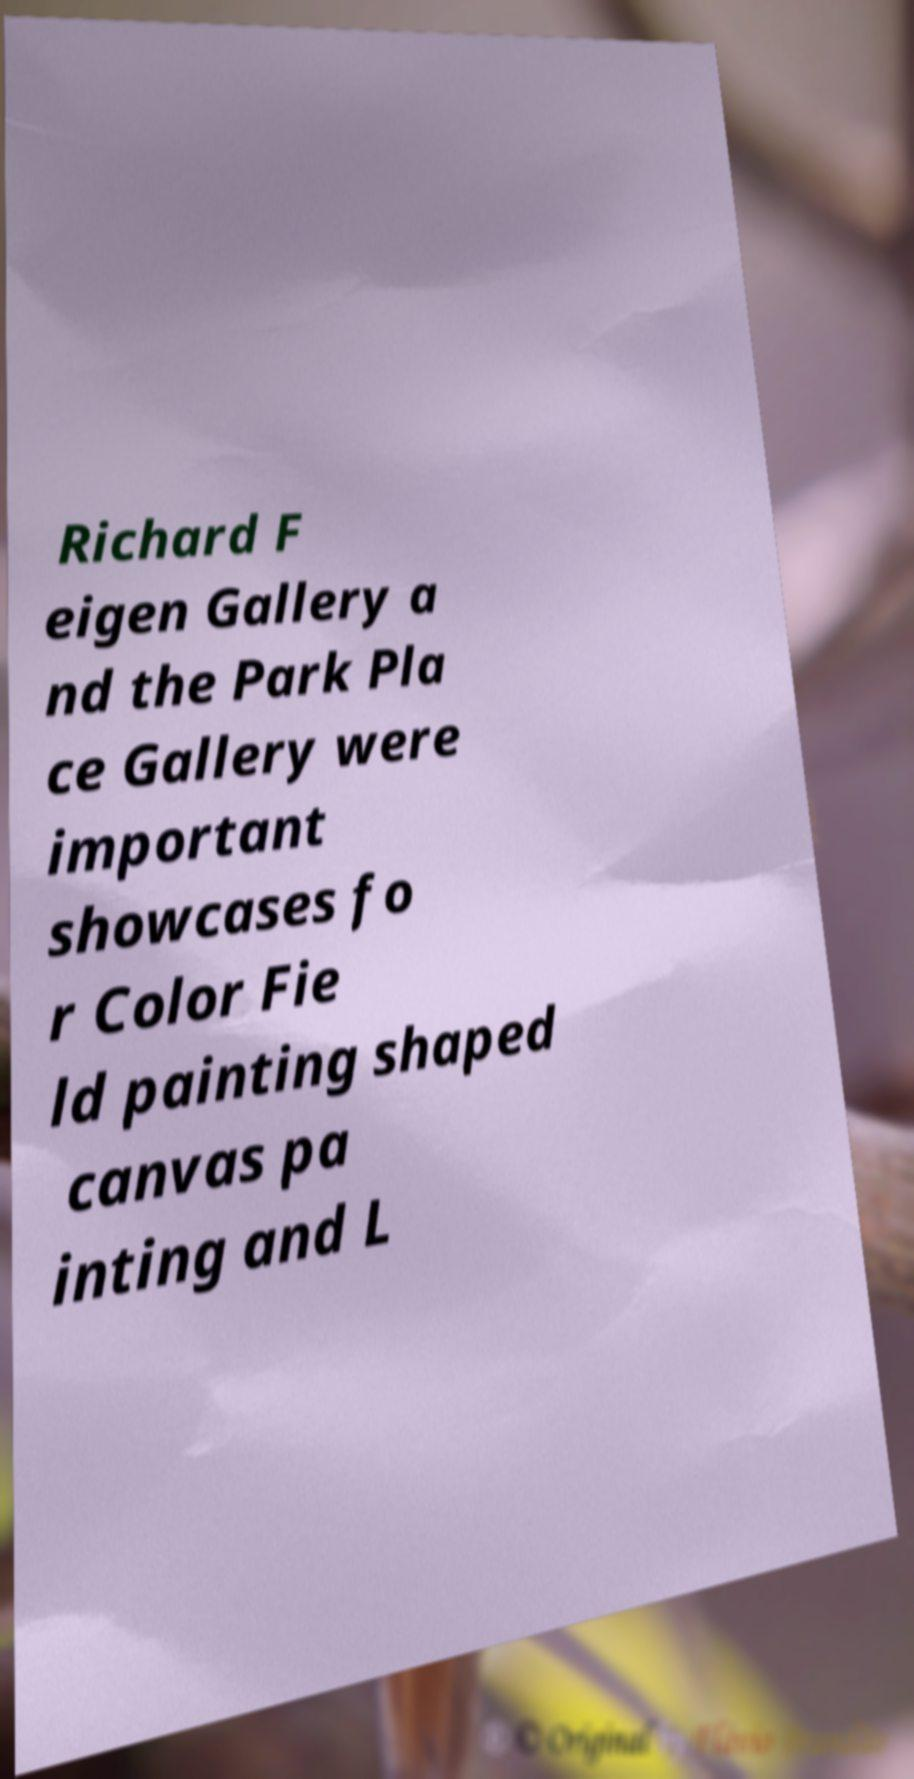Please read and relay the text visible in this image. What does it say? Richard F eigen Gallery a nd the Park Pla ce Gallery were important showcases fo r Color Fie ld painting shaped canvas pa inting and L 